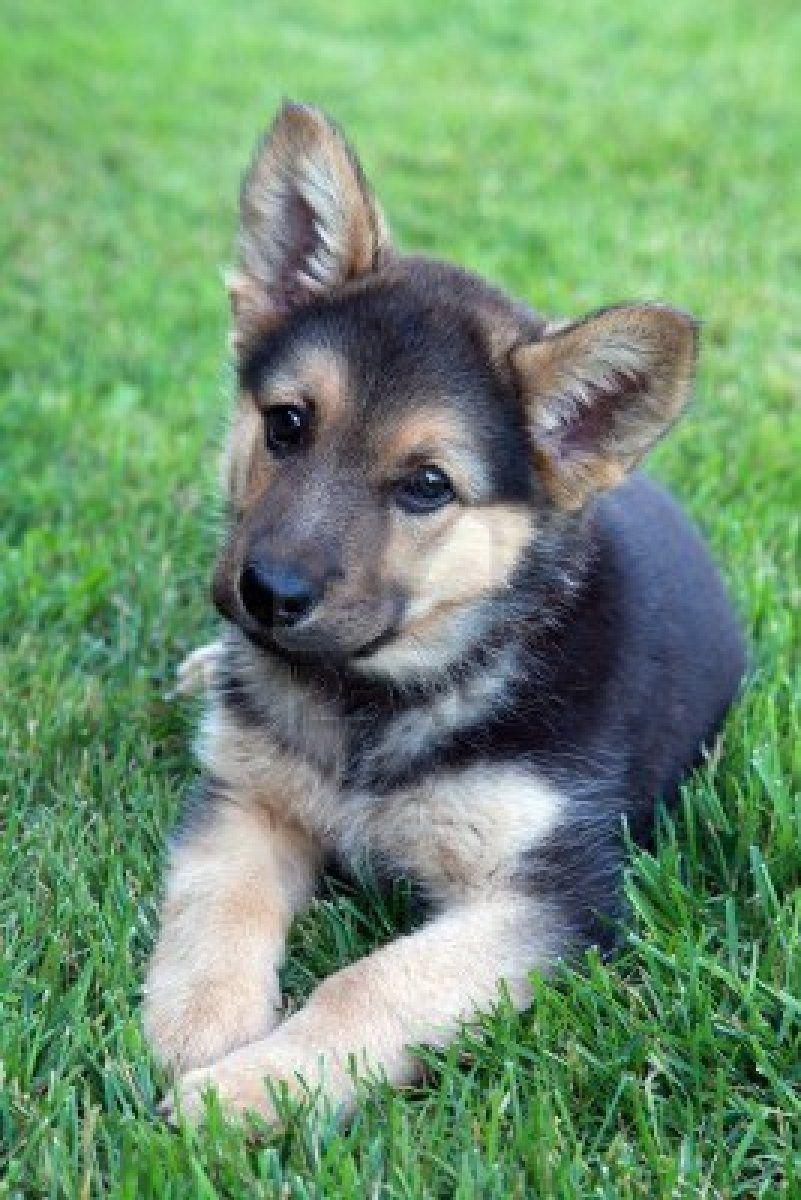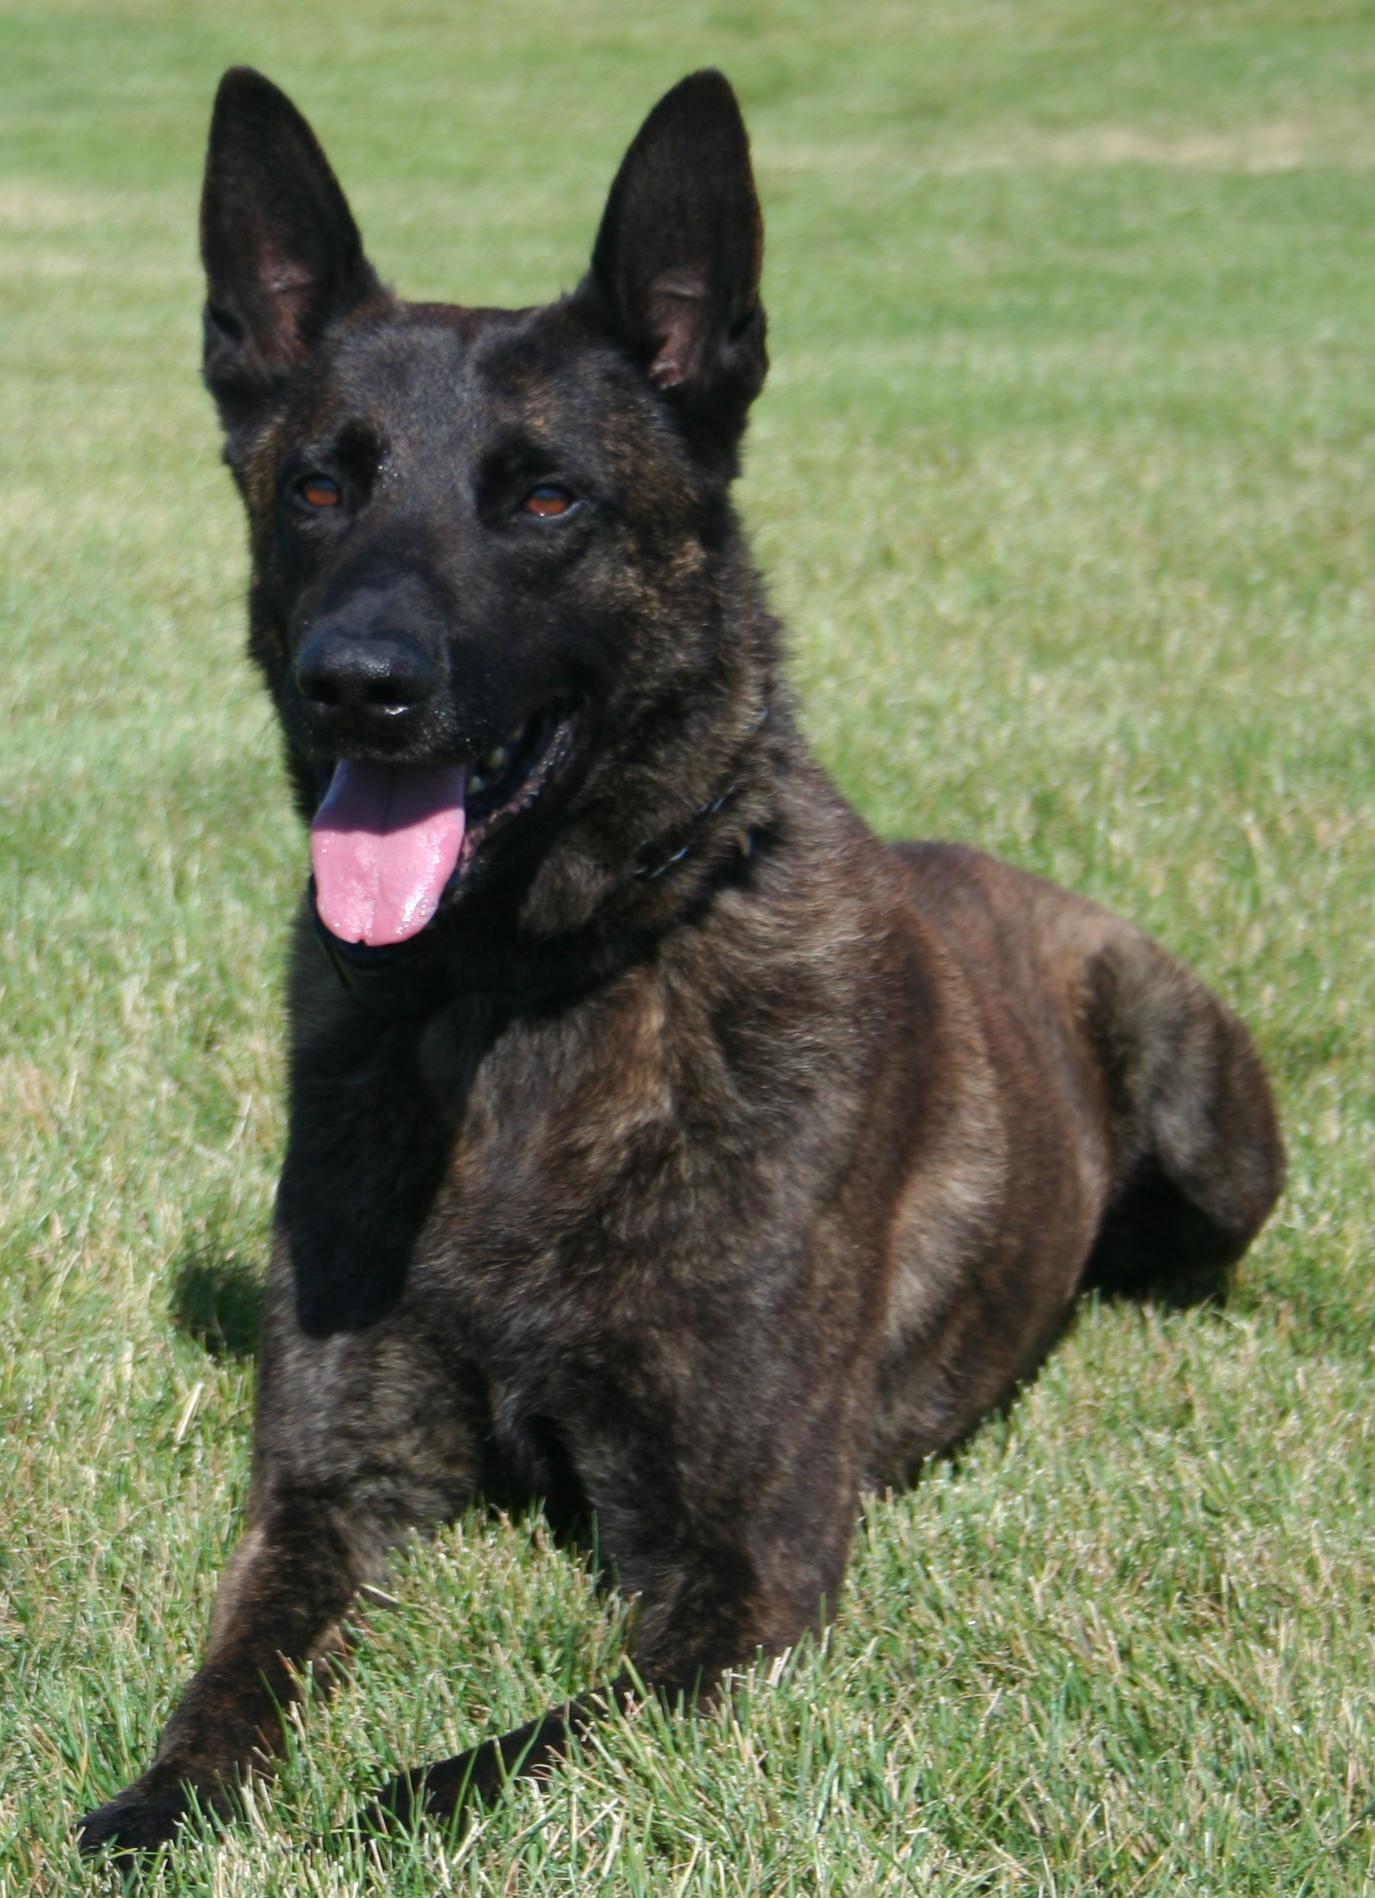The first image is the image on the left, the second image is the image on the right. Assess this claim about the two images: "All the dogs pictured are resting on the grassy ground.". Correct or not? Answer yes or no. Yes. 